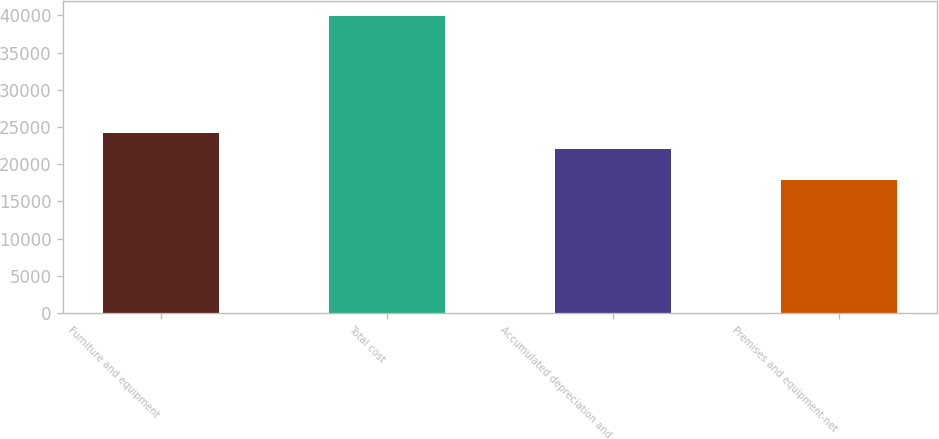Convert chart to OTSL. <chart><loc_0><loc_0><loc_500><loc_500><bar_chart><fcel>Furniture and equipment<fcel>Total cost<fcel>Accumulated depreciation and<fcel>Premises and equipment-net<nl><fcel>24246.2<fcel>39928<fcel>22042<fcel>17886<nl></chart> 